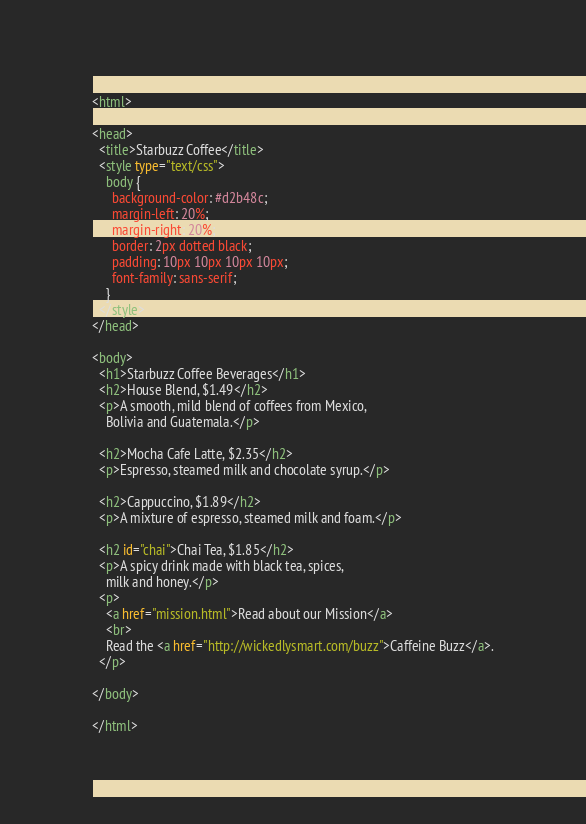Convert code to text. <code><loc_0><loc_0><loc_500><loc_500><_HTML_><html>

<head>
  <title>Starbuzz Coffee</title>
  <style type="text/css">
    body {
      background-color: #d2b48c;
      margin-left: 20%;
      margin-right: 20%;
      border: 2px dotted black;
      padding: 10px 10px 10px 10px;
      font-family: sans-serif;
    }
  </style>
</head>

<body>
  <h1>Starbuzz Coffee Beverages</h1>
  <h2>House Blend, $1.49</h2>
  <p>A smooth, mild blend of coffees from Mexico,
    Bolivia and Guatemala.</p>

  <h2>Mocha Cafe Latte, $2.35</h2>
  <p>Espresso, steamed milk and chocolate syrup.</p>

  <h2>Cappuccino, $1.89</h2>
  <p>A mixture of espresso, steamed milk and foam.</p>

  <h2 id="chai">Chai Tea, $1.85</h2>
  <p>A spicy drink made with black tea, spices,
    milk and honey.</p>
  <p>
    <a href="mission.html">Read about our Mission</a>
    <br>
    Read the <a href="http://wickedlysmart.com/buzz">Caffeine Buzz</a>.
  </p>

</body>

</html></code> 